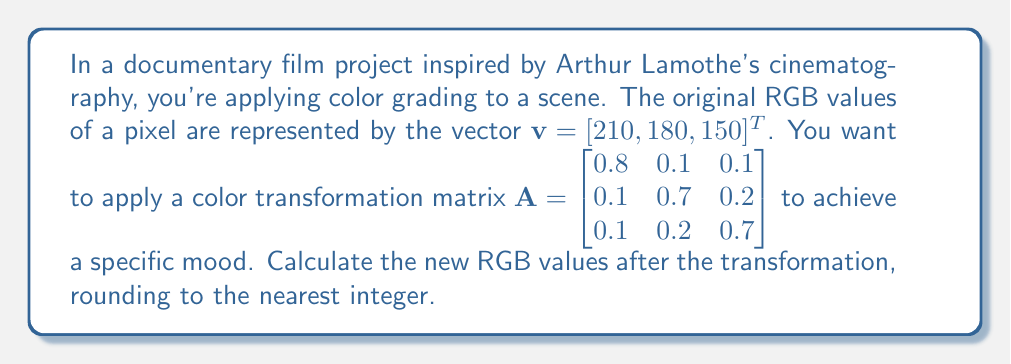Can you solve this math problem? To solve this problem, we'll follow these steps:

1) The color transformation is represented by the matrix multiplication:

   $$\mathbf{v}_{\text{new}} = \mathbf{A}\mathbf{v}$$

2) Let's perform this multiplication:

   $$\begin{bmatrix} 0.8 & 0.1 & 0.1 \\ 0.1 & 0.7 & 0.2 \\ 0.1 & 0.2 & 0.7 \end{bmatrix} \begin{bmatrix} 210 \\ 180 \\ 150 \end{bmatrix}$$

3) Calculating each component:

   For Red: $0.8(210) + 0.1(180) + 0.1(150) = 168 + 18 + 15 = 201$

   For Green: $0.1(210) + 0.7(180) + 0.2(150) = 21 + 126 + 30 = 177$

   For Blue: $0.1(210) + 0.2(180) + 0.7(150) = 21 + 36 + 105 = 162$

4) Rounding each value to the nearest integer:

   Red: 201 (already an integer)
   Green: 177 (already an integer)
   Blue: 162 (already an integer)

Therefore, the new RGB values after the transformation are [201, 177, 162].
Answer: [201, 177, 162] 